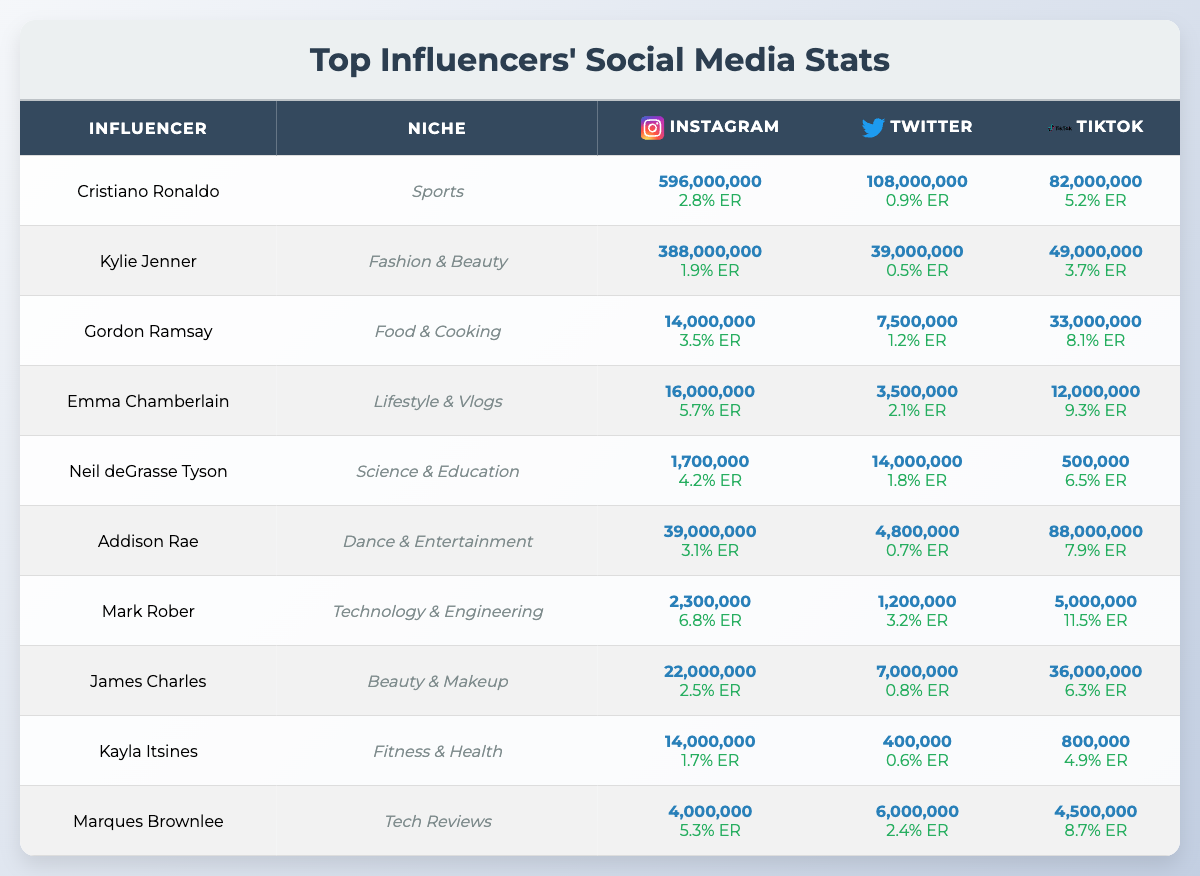What is Cristiano Ronaldo's engagement rate on Instagram? The table indicates that Cristiano Ronaldo's Instagram engagement rate is listed as 2.8%.
Answer: 2.8% Which influencer has the highest TikTok engagement rate? Looking at the TikTok engagement rates in the table, Emma Chamberlain has the highest at 9.3%.
Answer: Emma Chamberlain How many total Instagram followers do Gordon Ramsay and Kylie Jenner have combined? Adding their Instagram followers together: 14,000,000 (Gordon Ramsay) + 388,000,000 (Kylie Jenner) = 402,000,000.
Answer: 402,000,000 Is Neil deGrasse Tyson's Twitter engagement rate above 1%? The table shows Neil deGrasse Tyson's Twitter engagement rate as 1.8%, which is greater than 1%.
Answer: Yes What is the difference in TikTok followers between Addison Rae and James Charles? Addison Rae has 88,000,000 TikTok followers and James Charles has 36,000,000. The difference is 88,000,000 - 36,000,000 = 52,000,000.
Answer: 52,000,000 Who has the most followers on Twitter among the listed influencers? By examining the Twitter follower counts, Cristiano Ronaldo has the most with 108,000,000 followers.
Answer: Cristiano Ronaldo Calculate the average Instagram engagement rate of all influencers in the table. The engagement rates are 2.8, 1.9, 3.5, 5.7, 4.2, 3.1, 6.8, 2.5, 1.7, and 5.3. Summing these gives 35.5, and dividing by 10 (the number of influencers) results in an average of 3.55.
Answer: 3.55 Which niche has the influencer with the lowest engagement rate on Instagram? From inspecting the engagement rates, Kylie Jenner's is the lowest at 1.9% in the Fashion & Beauty niche.
Answer: Fashion & Beauty Does any influencer have more than 100 million followers combined across all platforms? By reviewing the follower counts, Cristiano Ronaldo has over 100 million followers when summing all platforms: 596,000,000 (Instagram) + 108,000,000 (Twitter) + 82,000,000 (TikTok) = 786,000,000. Thus, there are influencers with over 100 million combined.
Answer: Yes Identify the influencer in the "Food & Cooking" niche and their total follower count across all platforms. Gordon Ramsay is in the Food & Cooking niche with a total follower count of 14,000,000 (Instagram) + 7,500,000 (Twitter) + 33,000,000 (TikTok) = 54,500,000.
Answer: 54,500,000 